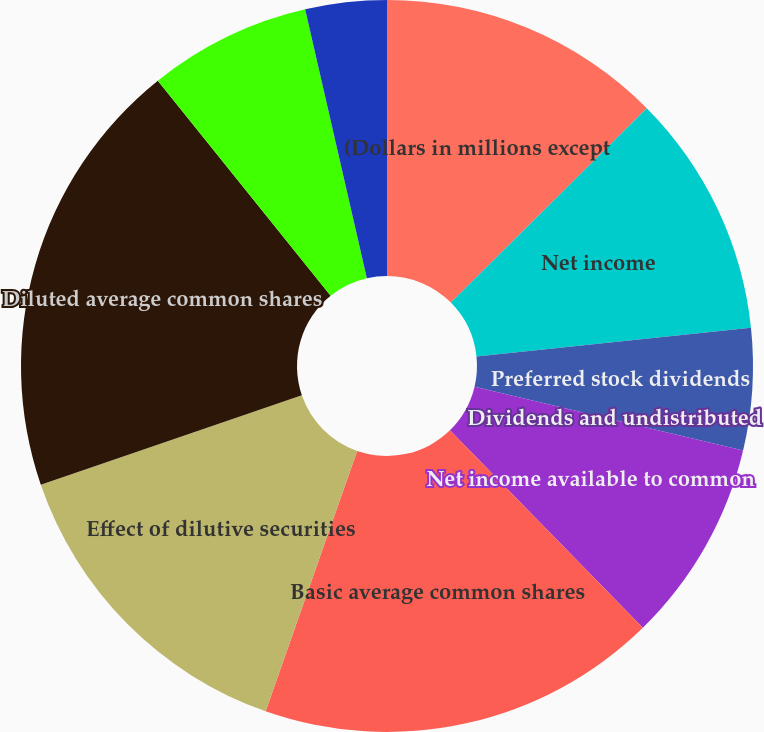Convert chart. <chart><loc_0><loc_0><loc_500><loc_500><pie_chart><fcel>(Dollars in millions except<fcel>Net income<fcel>Preferred stock dividends<fcel>Dividends and undistributed<fcel>Net income available to common<fcel>Basic average common shares<fcel>Effect of dilutive securities<fcel>Diluted average common shares<fcel>Anti-dilutive securities (2)<fcel>Basic<nl><fcel>12.56%<fcel>10.77%<fcel>5.38%<fcel>0.0%<fcel>8.97%<fcel>17.7%<fcel>14.36%<fcel>19.49%<fcel>7.18%<fcel>3.59%<nl></chart> 